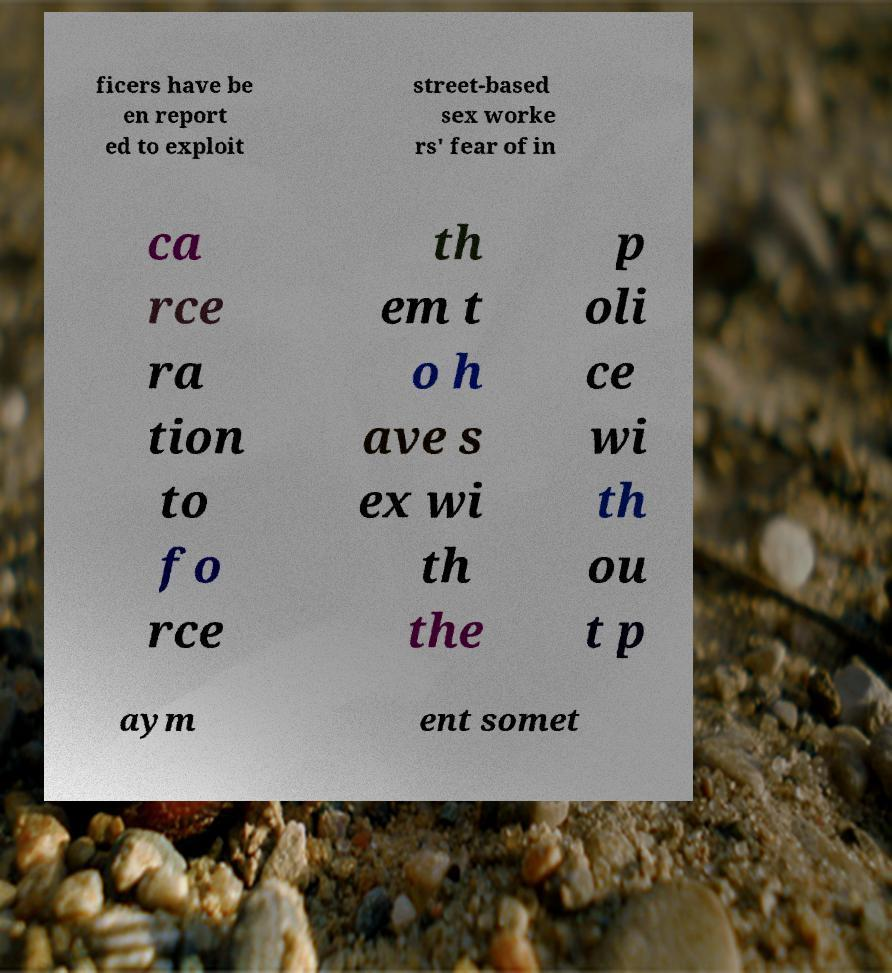Can you read and provide the text displayed in the image?This photo seems to have some interesting text. Can you extract and type it out for me? ficers have be en report ed to exploit street-based sex worke rs' fear of in ca rce ra tion to fo rce th em t o h ave s ex wi th the p oli ce wi th ou t p aym ent somet 